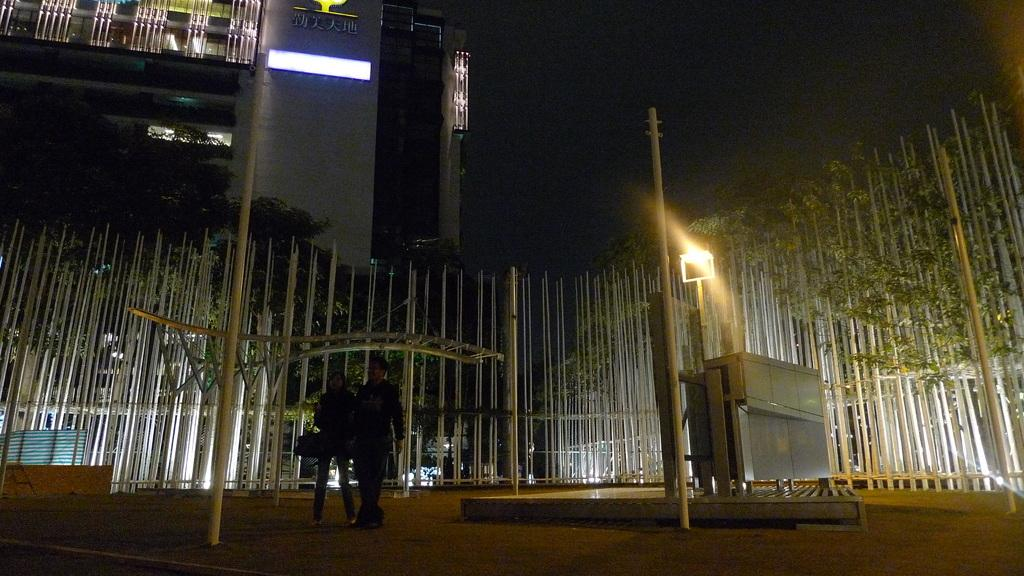What type of structure can be seen in the image? There is a building in the image. What natural elements are present in the image? There are trees in the image. Are there any people visible in the image? Yes, there are people standing in the image. What type of man-made objects can be seen in the image? There are poles and a pole light in the image. What other man-made object is present in the image? There is a metal box in the image. Can you tell me how many fish are swimming in the metal box in the image? There are no fish present in the image, and the metal box is not a body of water where fish could swim. 